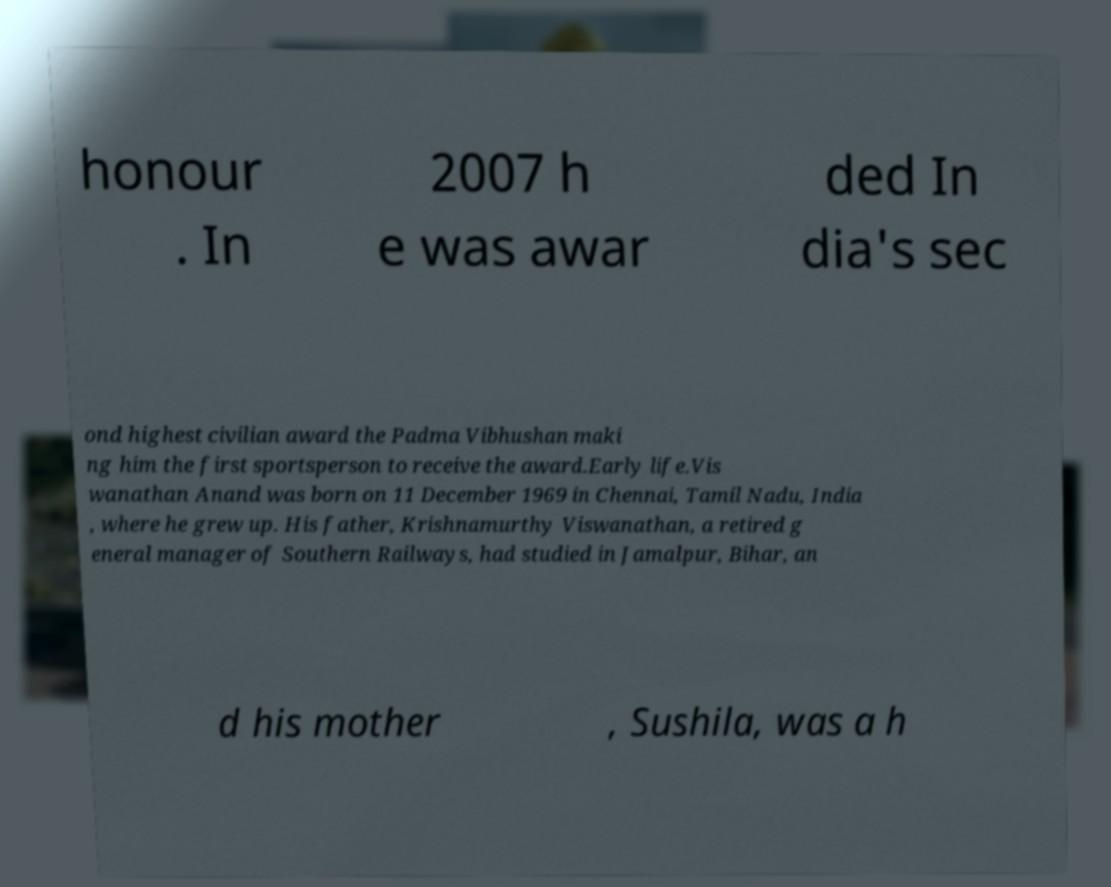Please read and relay the text visible in this image. What does it say? honour . In 2007 h e was awar ded In dia's sec ond highest civilian award the Padma Vibhushan maki ng him the first sportsperson to receive the award.Early life.Vis wanathan Anand was born on 11 December 1969 in Chennai, Tamil Nadu, India , where he grew up. His father, Krishnamurthy Viswanathan, a retired g eneral manager of Southern Railways, had studied in Jamalpur, Bihar, an d his mother , Sushila, was a h 